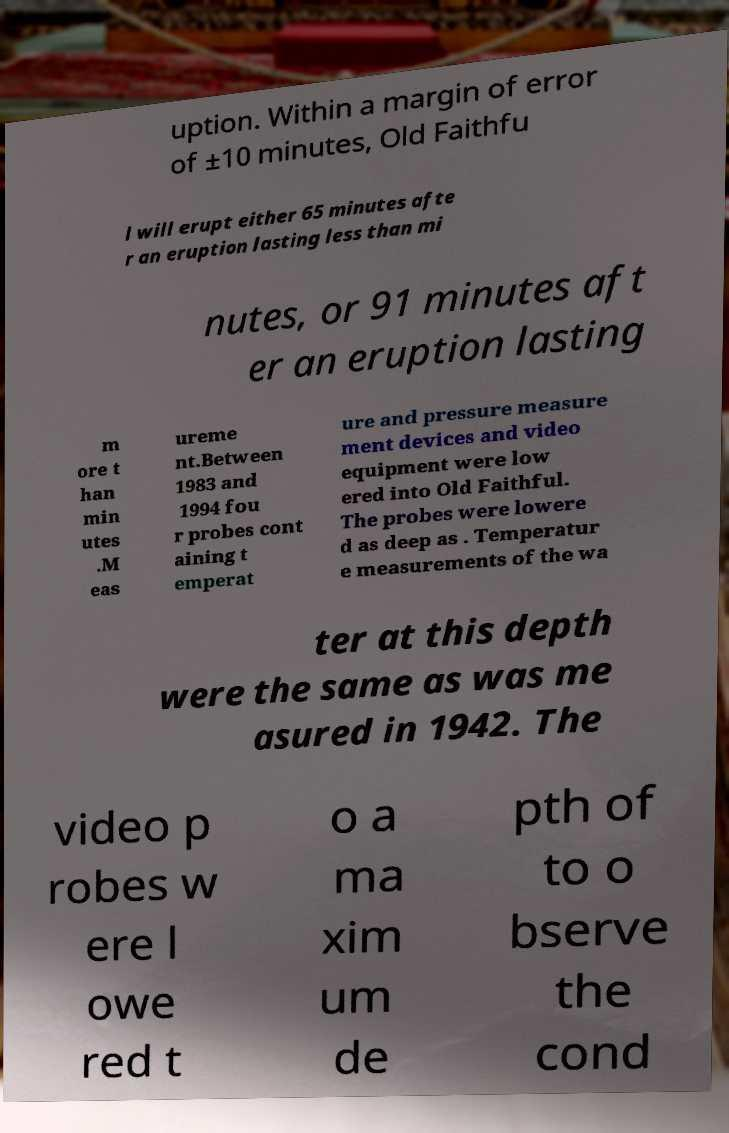Can you read and provide the text displayed in the image?This photo seems to have some interesting text. Can you extract and type it out for me? uption. Within a margin of error of ±10 minutes, Old Faithfu l will erupt either 65 minutes afte r an eruption lasting less than mi nutes, or 91 minutes aft er an eruption lasting m ore t han min utes .M eas ureme nt.Between 1983 and 1994 fou r probes cont aining t emperat ure and pressure measure ment devices and video equipment were low ered into Old Faithful. The probes were lowere d as deep as . Temperatur e measurements of the wa ter at this depth were the same as was me asured in 1942. The video p robes w ere l owe red t o a ma xim um de pth of to o bserve the cond 